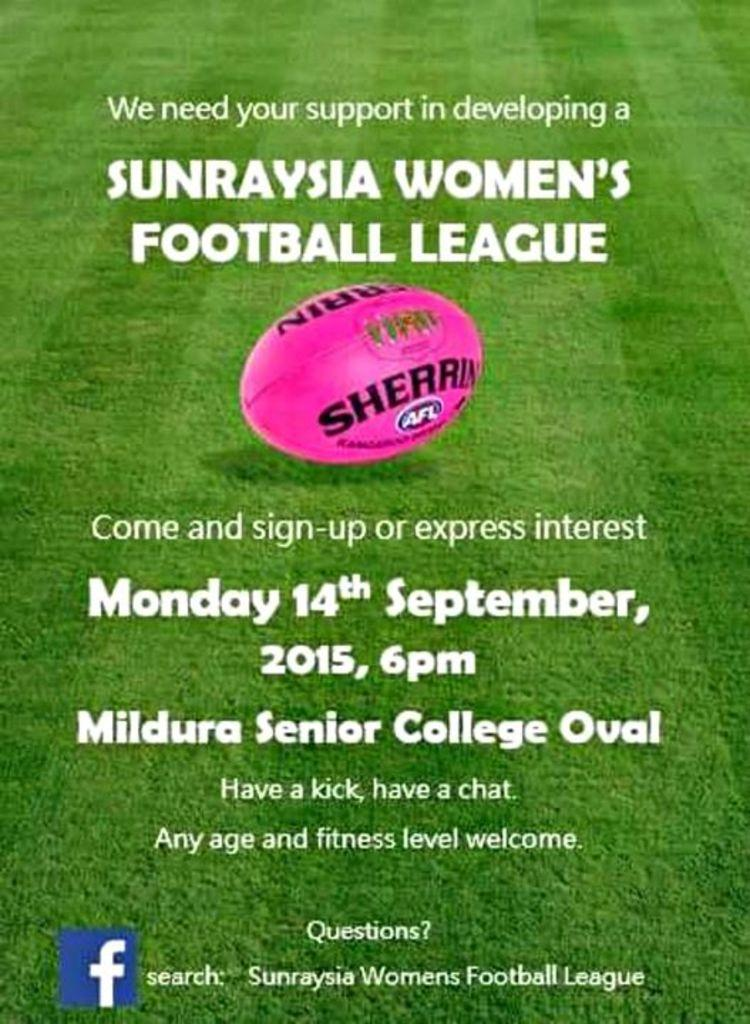What color is the ball in the image? The ball in the image is pink. What is the surface on which the ball is placed? The ball is placed on a green ground. What type of text is present above the ball? There is text written above the ball. What type of text is present below the ball? There is text written below the ball. How many babies are playing with the pink ball in the image? There are no babies present in the image. Are there any girls visible in the image? There is no information about girls in the provided facts, so we cannot determine if there are any girls in the image. 